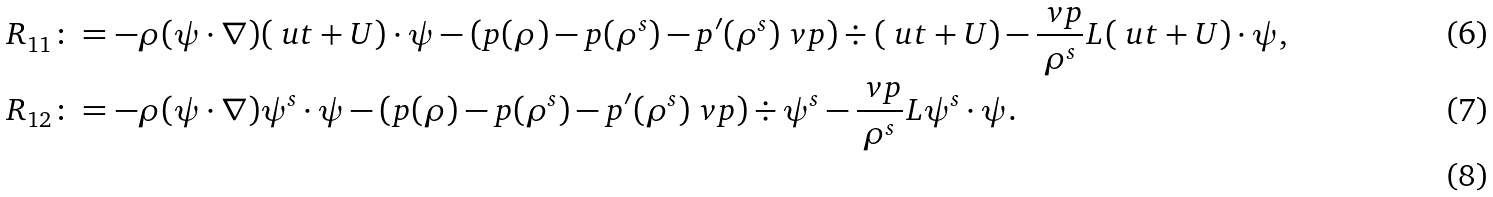Convert formula to latex. <formula><loc_0><loc_0><loc_500><loc_500>& R _ { 1 1 } \colon = - \rho ( \psi \cdot \nabla ) ( \ u t + U ) \cdot \psi - ( p ( \rho ) - p ( \rho ^ { s } ) - p ^ { \prime } ( \rho ^ { s } ) \ v p ) \div ( \ u t + U ) - \frac { \ v p } { \rho ^ { s } } L ( \ u t + U ) \cdot \psi , \\ & R _ { 1 2 } \colon = - \rho ( \psi \cdot \nabla ) \psi ^ { s } \cdot \psi - ( p ( \rho ) - p ( \rho ^ { s } ) - p ^ { \prime } ( \rho ^ { s } ) \ v p ) \div \psi ^ { s } - \frac { \ v p } { \rho ^ { s } } L \psi ^ { s } \cdot \psi . \\</formula> 